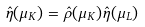<formula> <loc_0><loc_0><loc_500><loc_500>\hat { \eta } ( \mu _ { K } ) = \hat { \rho } ( \mu _ { K } ) \hat { \eta } ( \mu _ { L } )</formula> 